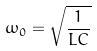<formula> <loc_0><loc_0><loc_500><loc_500>\omega _ { 0 } = \sqrt { \frac { 1 } { L C } }</formula> 